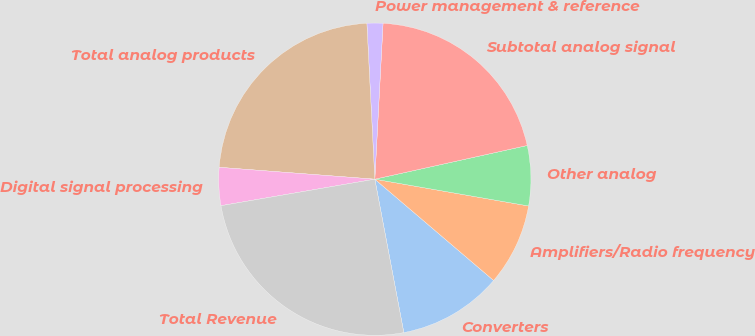Convert chart. <chart><loc_0><loc_0><loc_500><loc_500><pie_chart><fcel>Converters<fcel>Amplifiers/Radio frequency<fcel>Other analog<fcel>Subtotal analog signal<fcel>Power management & reference<fcel>Total analog products<fcel>Digital signal processing<fcel>Total Revenue<nl><fcel>10.79%<fcel>8.49%<fcel>6.21%<fcel>20.7%<fcel>1.65%<fcel>22.98%<fcel>3.93%<fcel>25.26%<nl></chart> 